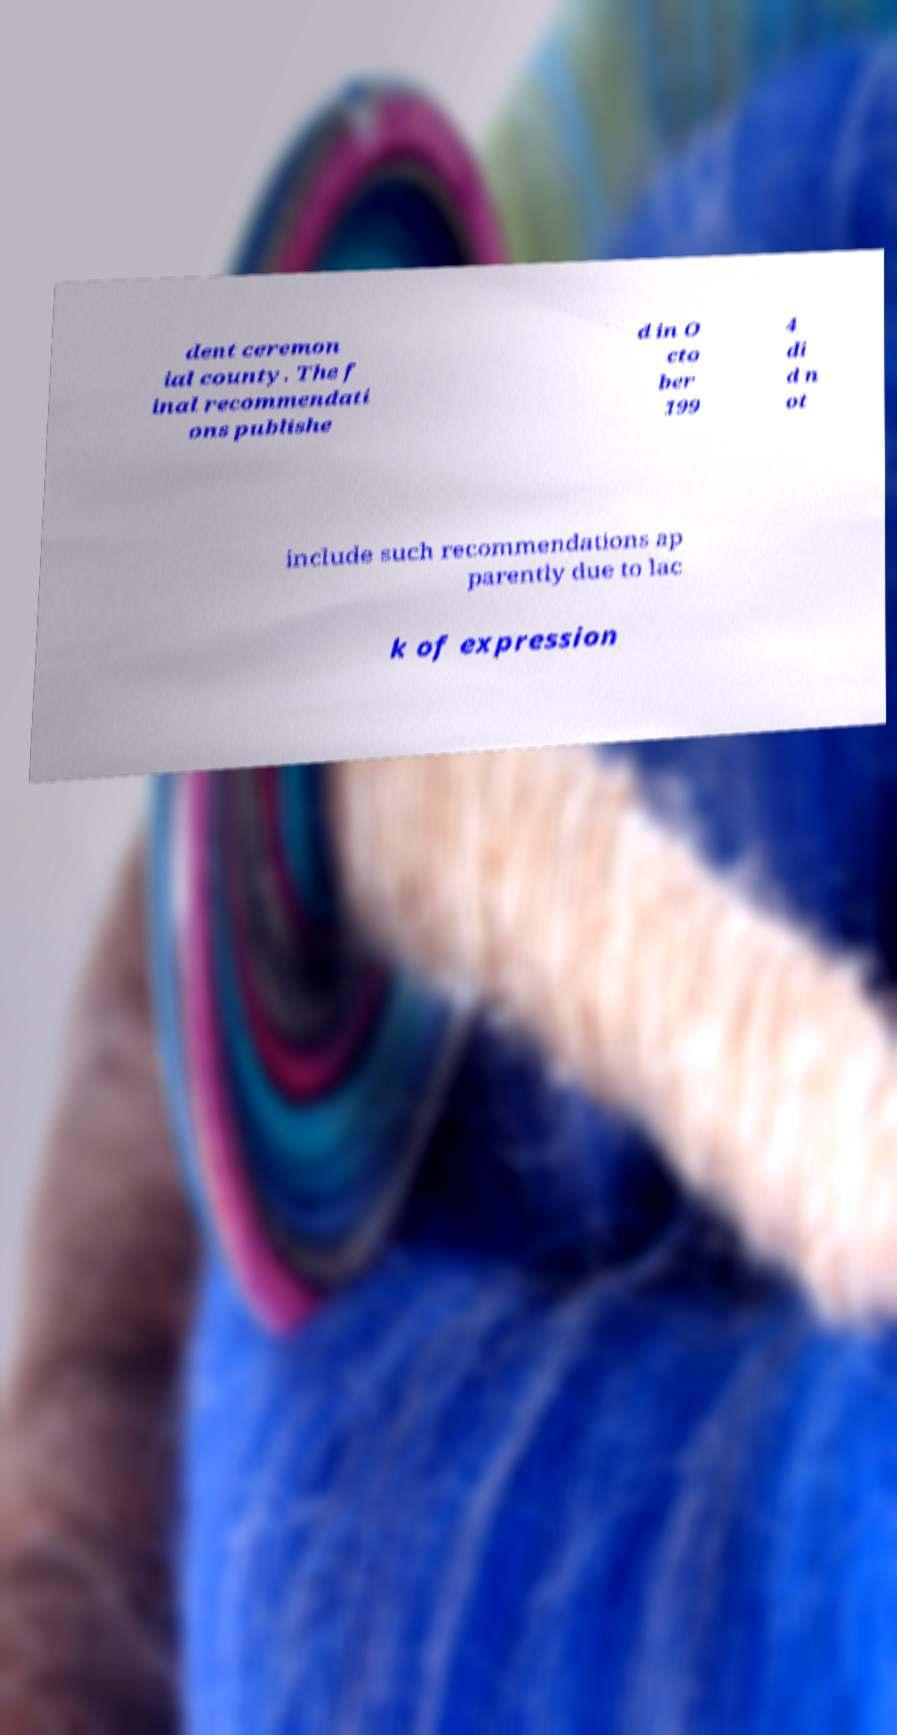I need the written content from this picture converted into text. Can you do that? dent ceremon ial county. The f inal recommendati ons publishe d in O cto ber 199 4 di d n ot include such recommendations ap parently due to lac k of expression 